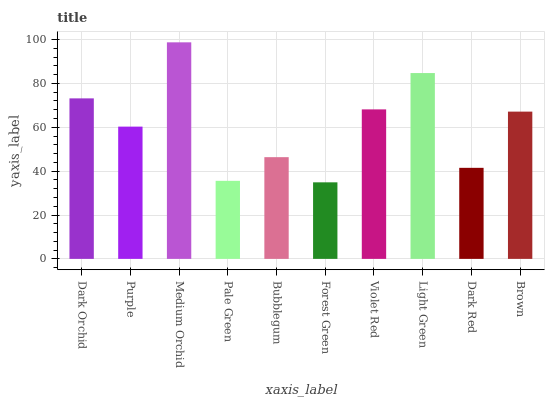Is Forest Green the minimum?
Answer yes or no. Yes. Is Medium Orchid the maximum?
Answer yes or no. Yes. Is Purple the minimum?
Answer yes or no. No. Is Purple the maximum?
Answer yes or no. No. Is Dark Orchid greater than Purple?
Answer yes or no. Yes. Is Purple less than Dark Orchid?
Answer yes or no. Yes. Is Purple greater than Dark Orchid?
Answer yes or no. No. Is Dark Orchid less than Purple?
Answer yes or no. No. Is Brown the high median?
Answer yes or no. Yes. Is Purple the low median?
Answer yes or no. Yes. Is Light Green the high median?
Answer yes or no. No. Is Medium Orchid the low median?
Answer yes or no. No. 